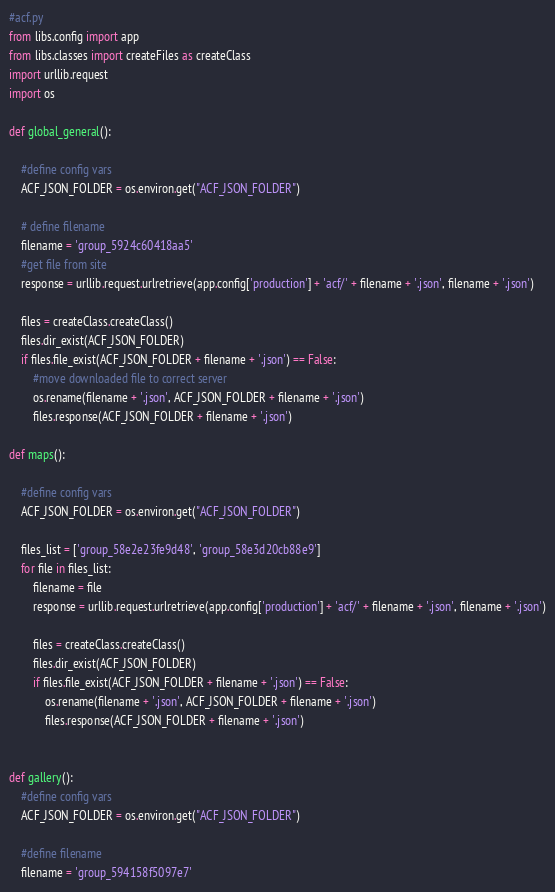Convert code to text. <code><loc_0><loc_0><loc_500><loc_500><_Python_>#acf.py
from libs.config import app
from libs.classes import createFiles as createClass
import urllib.request
import os

def global_general():

	#define config vars
	ACF_JSON_FOLDER = os.environ.get("ACF_JSON_FOLDER")

	# define filename
	filename = 'group_5924c60418aa5'
	#get file from site
	response = urllib.request.urlretrieve(app.config['production'] + 'acf/' + filename + '.json', filename + '.json')
	
	files = createClass.createClass()
	files.dir_exist(ACF_JSON_FOLDER)
	if files.file_exist(ACF_JSON_FOLDER + filename + '.json') == False:
		#move downloaded file to correct server
		os.rename(filename + '.json', ACF_JSON_FOLDER + filename + '.json')
		files.response(ACF_JSON_FOLDER + filename + '.json')

def maps():

	#define config vars
	ACF_JSON_FOLDER = os.environ.get("ACF_JSON_FOLDER")

	files_list = ['group_58e2e23fe9d48', 'group_58e3d20cb88e9']
	for file in files_list:
		filename = file
		response = urllib.request.urlretrieve(app.config['production'] + 'acf/' + filename + '.json', filename + '.json')
	
		files = createClass.createClass()
		files.dir_exist(ACF_JSON_FOLDER)
		if files.file_exist(ACF_JSON_FOLDER + filename + '.json') == False:
			os.rename(filename + '.json', ACF_JSON_FOLDER + filename + '.json')
			files.response(ACF_JSON_FOLDER + filename + '.json')


def gallery():
	#define config vars
	ACF_JSON_FOLDER = os.environ.get("ACF_JSON_FOLDER")
	
	#define filename
	filename = 'group_594158f5097e7'</code> 